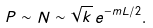<formula> <loc_0><loc_0><loc_500><loc_500>P \sim N \sim \sqrt { k } \, e ^ { - m L / 2 } .</formula> 